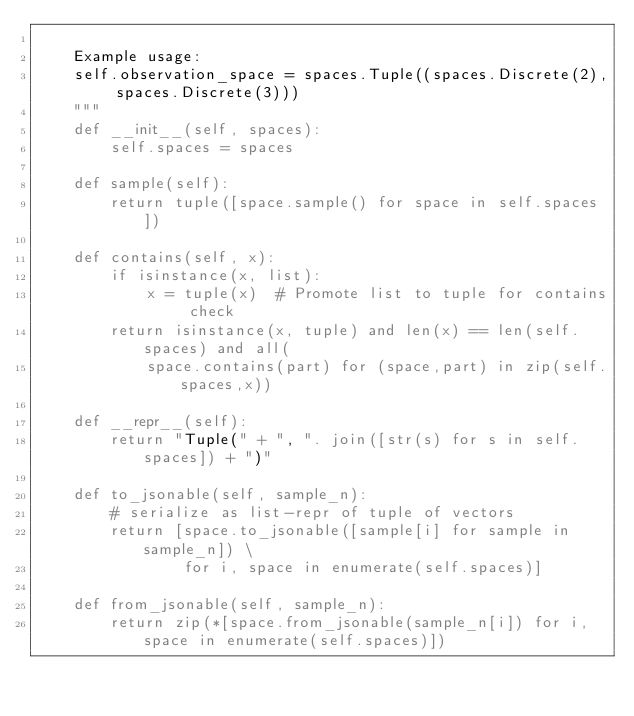Convert code to text. <code><loc_0><loc_0><loc_500><loc_500><_Python_>
    Example usage:
    self.observation_space = spaces.Tuple((spaces.Discrete(2), spaces.Discrete(3)))
    """
    def __init__(self, spaces):
        self.spaces = spaces

    def sample(self):
        return tuple([space.sample() for space in self.spaces])

    def contains(self, x):
        if isinstance(x, list):
            x = tuple(x)  # Promote list to tuple for contains check
        return isinstance(x, tuple) and len(x) == len(self.spaces) and all(
            space.contains(part) for (space,part) in zip(self.spaces,x))

    def __repr__(self):
        return "Tuple(" + ", ". join([str(s) for s in self.spaces]) + ")"

    def to_jsonable(self, sample_n):
        # serialize as list-repr of tuple of vectors
        return [space.to_jsonable([sample[i] for sample in sample_n]) \
                for i, space in enumerate(self.spaces)]

    def from_jsonable(self, sample_n):
        return zip(*[space.from_jsonable(sample_n[i]) for i, space in enumerate(self.spaces)])
</code> 